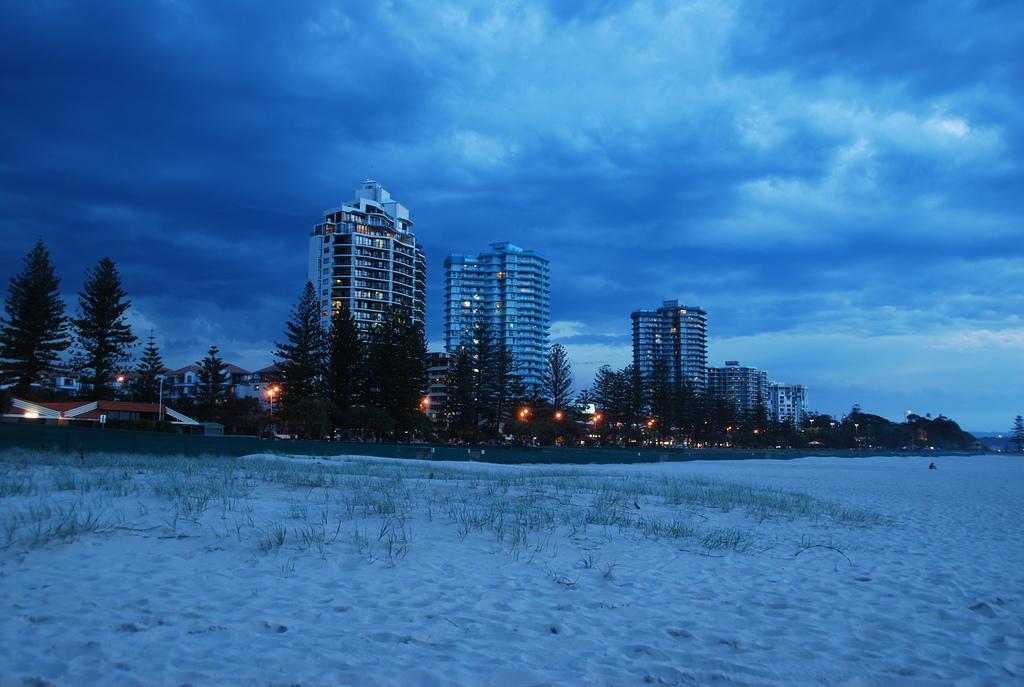Describe this image in one or two sentences. In this picture we can see snow at the bottom, in the background there are some buildings, trees, lights and poles, there is the sky and clouds at the top of the picture, we can see some grass at the bottom. 